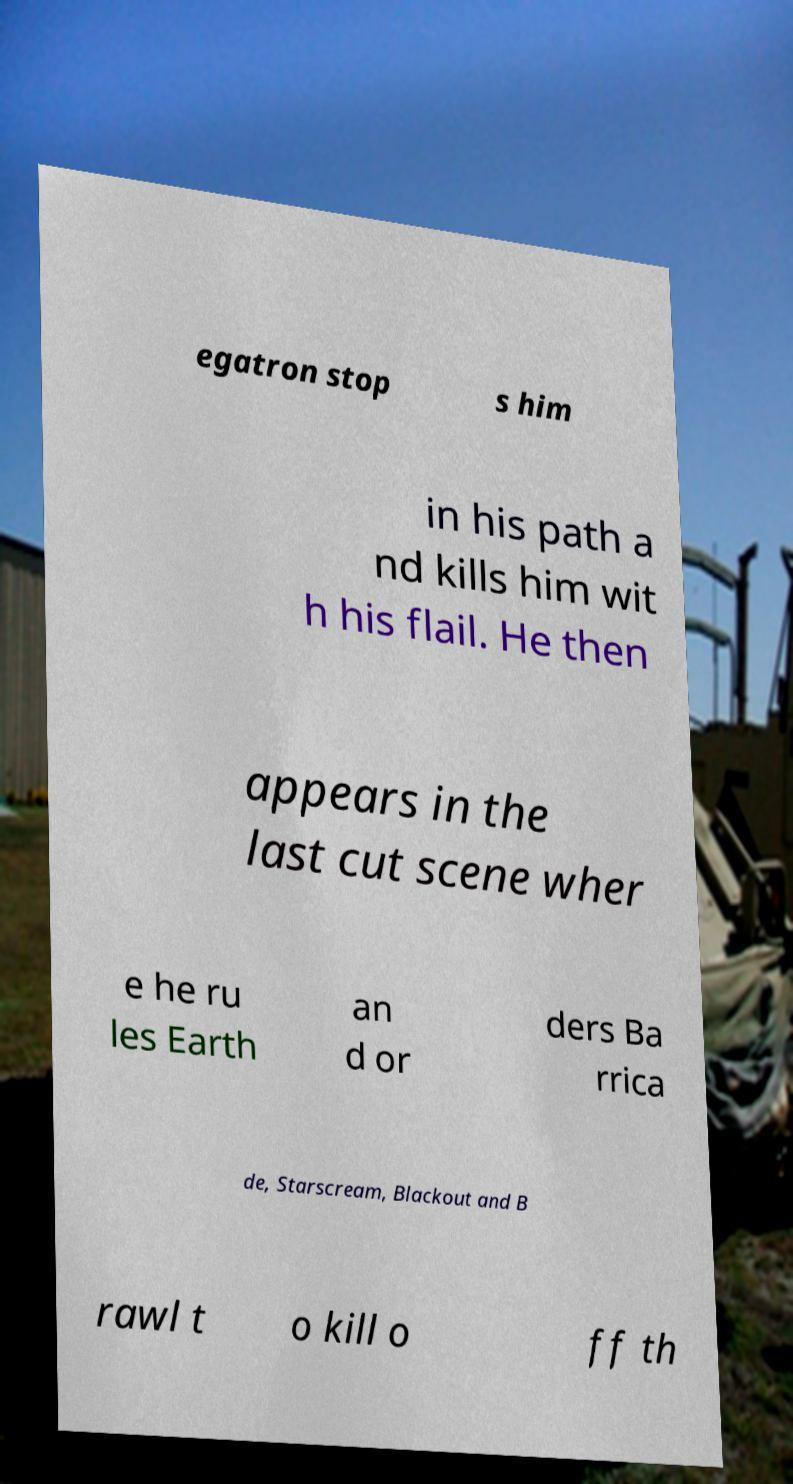What messages or text are displayed in this image? I need them in a readable, typed format. egatron stop s him in his path a nd kills him wit h his flail. He then appears in the last cut scene wher e he ru les Earth an d or ders Ba rrica de, Starscream, Blackout and B rawl t o kill o ff th 